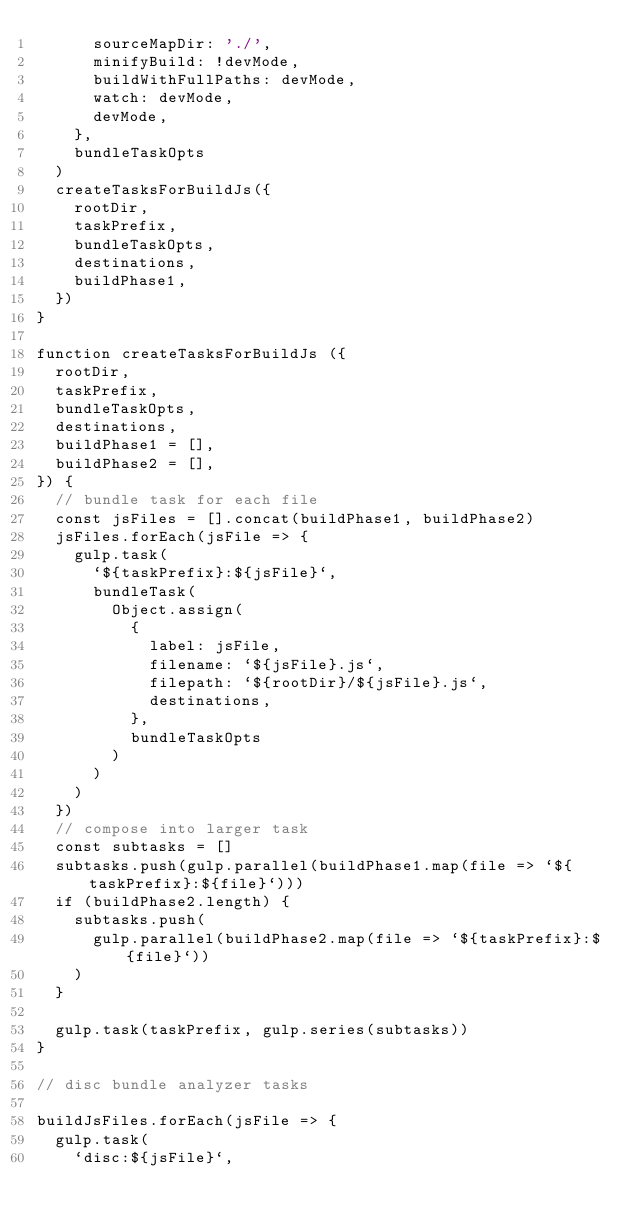Convert code to text. <code><loc_0><loc_0><loc_500><loc_500><_JavaScript_>      sourceMapDir: './',
      minifyBuild: !devMode,
      buildWithFullPaths: devMode,
      watch: devMode,
      devMode,
    },
    bundleTaskOpts
  )
  createTasksForBuildJs({
    rootDir,
    taskPrefix,
    bundleTaskOpts,
    destinations,
    buildPhase1,
  })
}

function createTasksForBuildJs ({
  rootDir,
  taskPrefix,
  bundleTaskOpts,
  destinations,
  buildPhase1 = [],
  buildPhase2 = [],
}) {
  // bundle task for each file
  const jsFiles = [].concat(buildPhase1, buildPhase2)
  jsFiles.forEach(jsFile => {
    gulp.task(
      `${taskPrefix}:${jsFile}`,
      bundleTask(
        Object.assign(
          {
            label: jsFile,
            filename: `${jsFile}.js`,
            filepath: `${rootDir}/${jsFile}.js`,
            destinations,
          },
          bundleTaskOpts
        )
      )
    )
  })
  // compose into larger task
  const subtasks = []
  subtasks.push(gulp.parallel(buildPhase1.map(file => `${taskPrefix}:${file}`)))
  if (buildPhase2.length) {
    subtasks.push(
      gulp.parallel(buildPhase2.map(file => `${taskPrefix}:${file}`))
    )
  }

  gulp.task(taskPrefix, gulp.series(subtasks))
}

// disc bundle analyzer tasks

buildJsFiles.forEach(jsFile => {
  gulp.task(
    `disc:${jsFile}`,</code> 